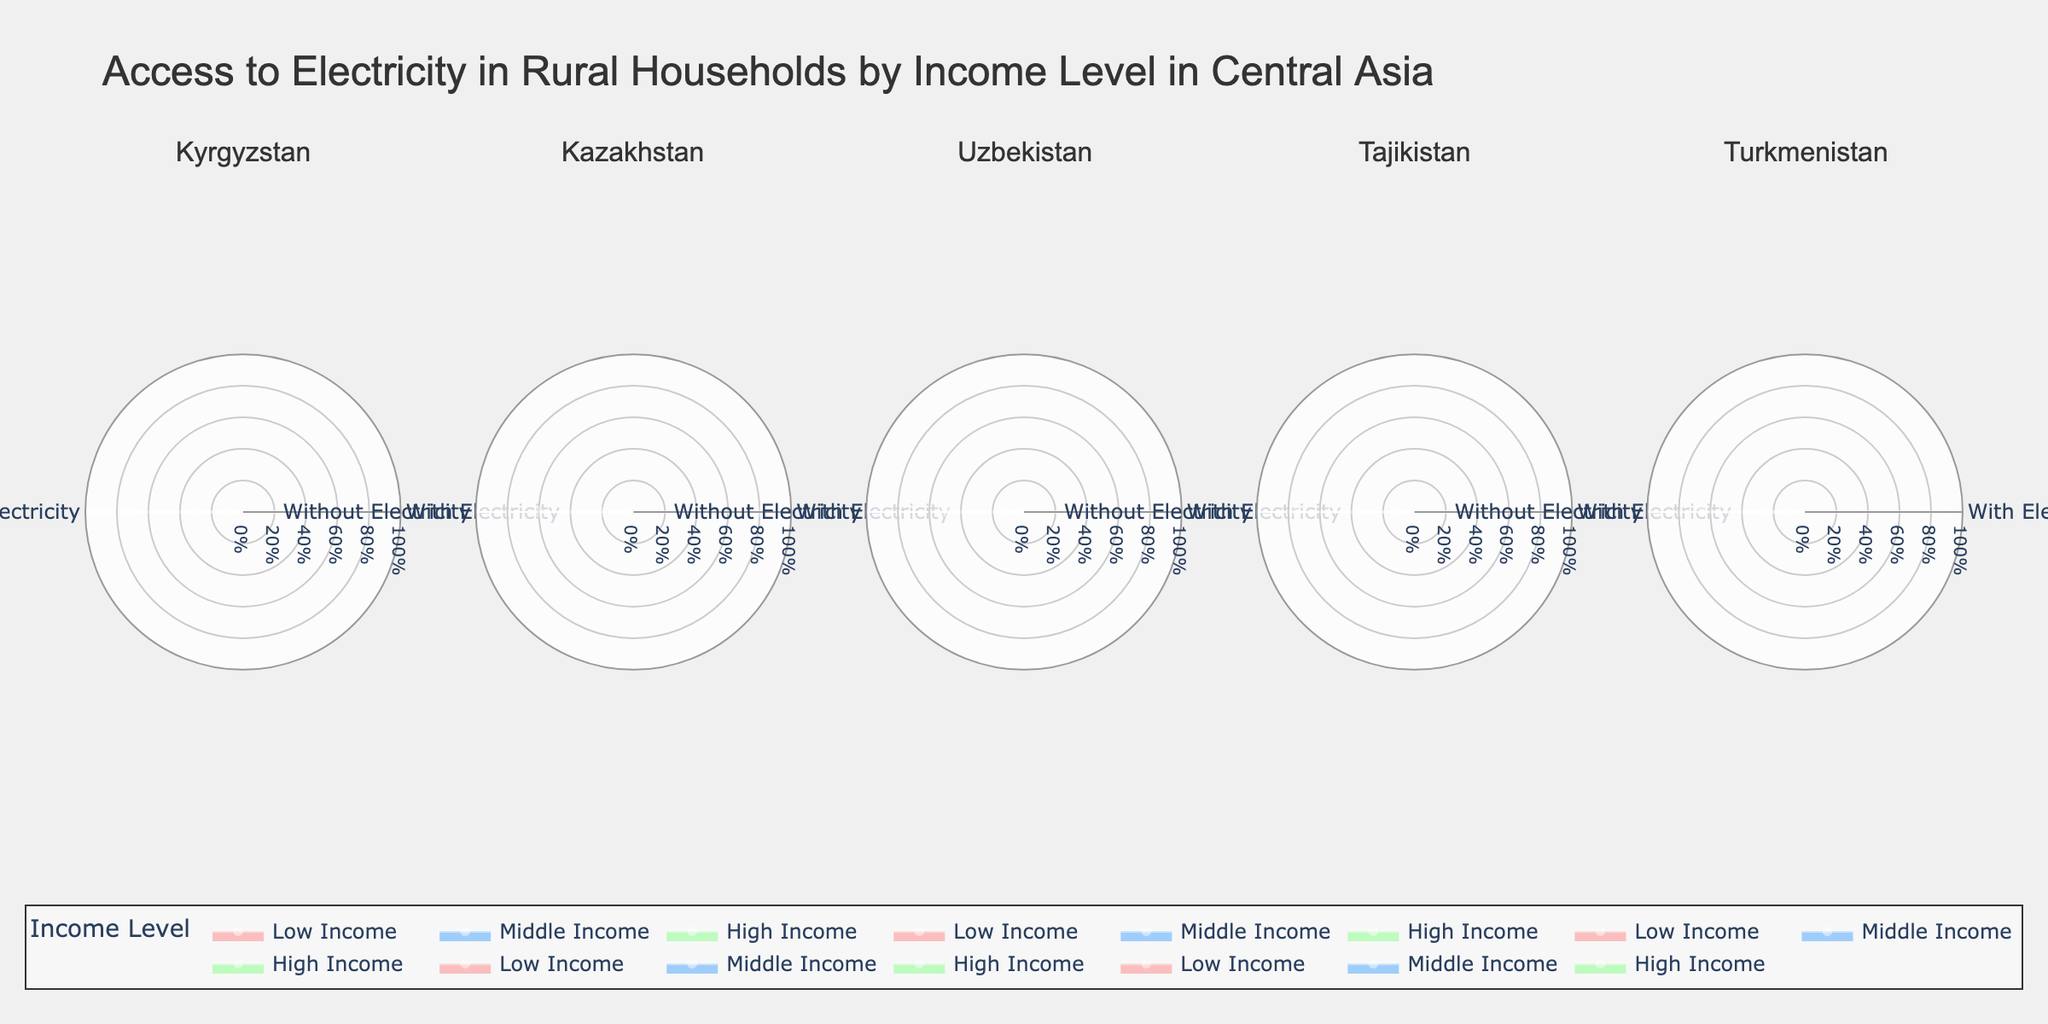What is the title of the figure? The title of the figure is located at the top of the plot and it gives a summary of what the figure represents.
Answer: Access to Electricity in Rural Households by Income Level in Central Asia Which region has the highest percentage of households without electricity for low-income levels? By examining the plot for the low-income category across each region, the radial values represent the percentage of households without electricity. Tajikistan has the highest percentage at 75%.
Answer: Tajikistan Compare the access to electricity among high-income households in Kazakhstan and Uzbekistan. Which region has a higher percentage? Find the radial value for high-income households labeled with electricity access in both Kazakhstan and Uzbekistan. Kazakhstan shows 95% while Uzbekistan shows 98%.
Answer: Uzbekistan What is the color used for middle-income categories? The color scheme for different income categories is provided in the legend. Middle-income categories are indicated with a specific color shade.
Answer: Light blue In Kyrgyzstan, calculate the differential percentage of households without electricity between low and high income groups. Subtract the percentage of households without electricity for the high-income group from that of the low-income group in Kyrgyzstan. 70% (low-income) - 10% (high-income) = 60%.
Answer: 60% How does the electricity access for low-income households in Uzbekistan compare to Turkmenistan? Compare the radial values of low-income categories in Uzbekistan and Turkmenistan, focusing on the segment with access to electricity. Uzbekistan has 50% while Turkmenistan has 35%.
Answer: Uzbekistan is higher What percentage of middle-income households in Tajikistan have electricity access? The plot for middle-income households in Tajikistan indicates the radial value for the segment with electricity access, which is 65%.
Answer: 65% Is the percentage of households without electricity higher for low-income groups in Kazakhstan or Kyrgyzstan? Compare the radial values of low-income groups in both Kazakhstan and Kyrgyzstan, highlighting the segment without electricity. Kazakhstan shows 60%, while Kyrgyzstan shows 70%.
Answer: Kyrgyzstan Identify the region where middle-income households have a higher percentage of electricity access compared to the other mentioned regions. Analyze the plots for middle-income households in all regions and check their electricity access percentages. Uzbekistan has the highest percentage at 85%.
Answer: Uzbekistan 